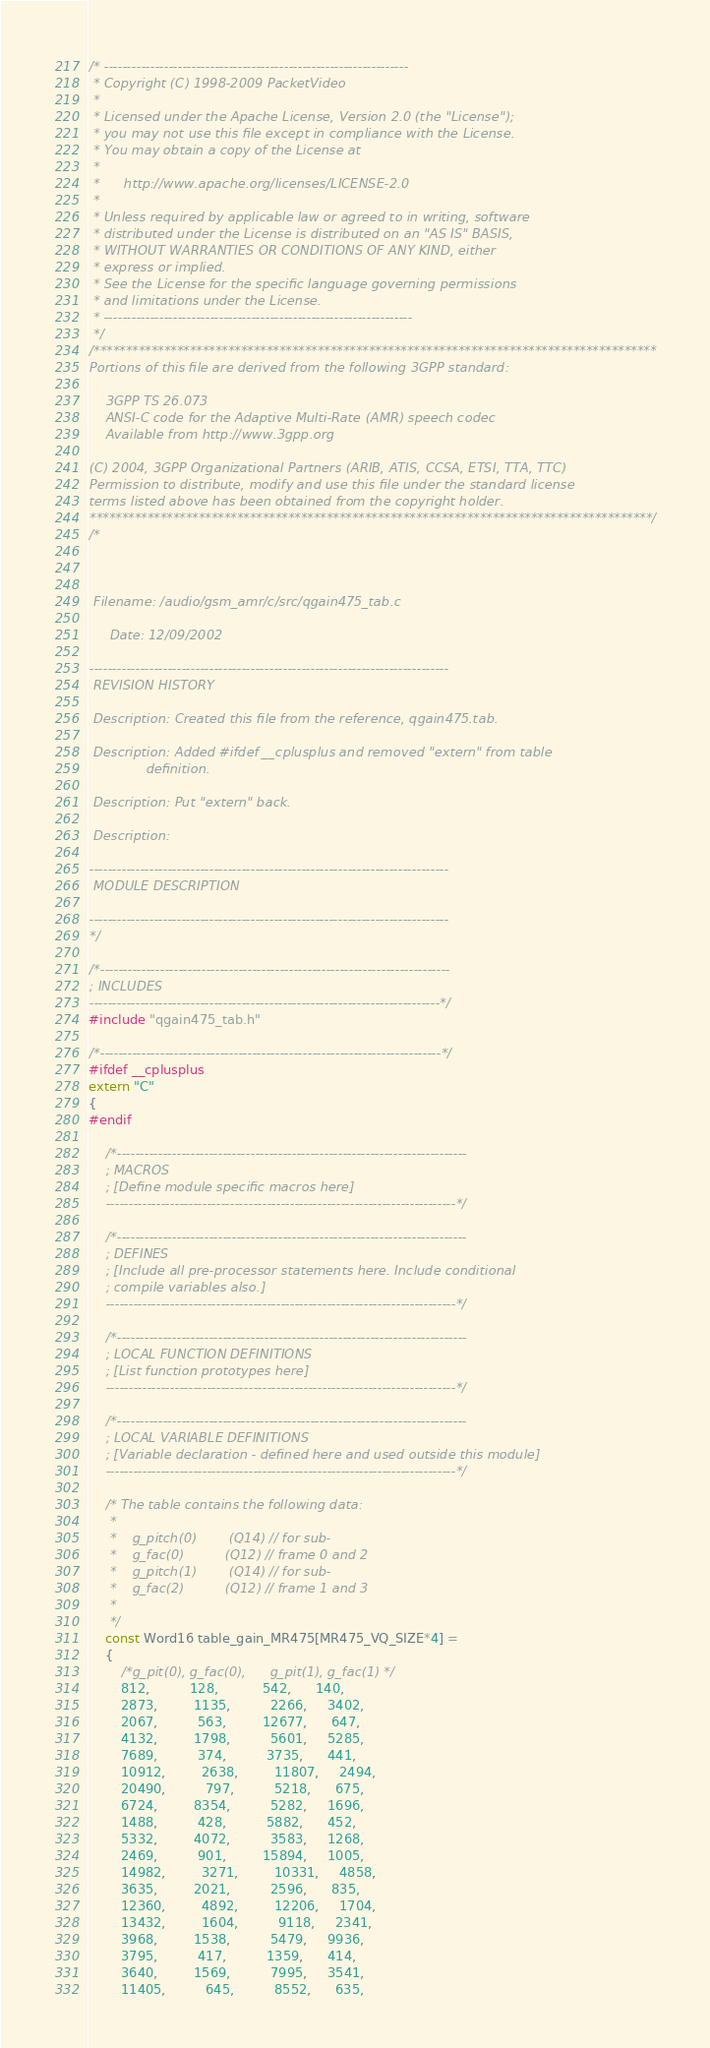<code> <loc_0><loc_0><loc_500><loc_500><_C++_>/* ------------------------------------------------------------------
 * Copyright (C) 1998-2009 PacketVideo
 *
 * Licensed under the Apache License, Version 2.0 (the "License");
 * you may not use this file except in compliance with the License.
 * You may obtain a copy of the License at
 *
 *      http://www.apache.org/licenses/LICENSE-2.0
 *
 * Unless required by applicable law or agreed to in writing, software
 * distributed under the License is distributed on an "AS IS" BASIS,
 * WITHOUT WARRANTIES OR CONDITIONS OF ANY KIND, either
 * express or implied.
 * See the License for the specific language governing permissions
 * and limitations under the License.
 * -------------------------------------------------------------------
 */
/****************************************************************************************
Portions of this file are derived from the following 3GPP standard:

    3GPP TS 26.073
    ANSI-C code for the Adaptive Multi-Rate (AMR) speech codec
    Available from http://www.3gpp.org

(C) 2004, 3GPP Organizational Partners (ARIB, ATIS, CCSA, ETSI, TTA, TTC)
Permission to distribute, modify and use this file under the standard license
terms listed above has been obtained from the copyright holder.
****************************************************************************************/
/*



 Filename: /audio/gsm_amr/c/src/qgain475_tab.c

     Date: 12/09/2002

------------------------------------------------------------------------------
 REVISION HISTORY

 Description: Created this file from the reference, qgain475.tab.

 Description: Added #ifdef __cplusplus and removed "extern" from table
              definition.

 Description: Put "extern" back.

 Description:

------------------------------------------------------------------------------
 MODULE DESCRIPTION

------------------------------------------------------------------------------
*/

/*----------------------------------------------------------------------------
; INCLUDES
----------------------------------------------------------------------------*/
#include "qgain475_tab.h"

/*--------------------------------------------------------------------------*/
#ifdef __cplusplus
extern "C"
{
#endif

    /*----------------------------------------------------------------------------
    ; MACROS
    ; [Define module specific macros here]
    ----------------------------------------------------------------------------*/

    /*----------------------------------------------------------------------------
    ; DEFINES
    ; [Include all pre-processor statements here. Include conditional
    ; compile variables also.]
    ----------------------------------------------------------------------------*/

    /*----------------------------------------------------------------------------
    ; LOCAL FUNCTION DEFINITIONS
    ; [List function prototypes here]
    ----------------------------------------------------------------------------*/

    /*----------------------------------------------------------------------------
    ; LOCAL VARIABLE DEFINITIONS
    ; [Variable declaration - defined here and used outside this module]
    ----------------------------------------------------------------------------*/

    /* The table contains the following data:
     *
     *    g_pitch(0)        (Q14) // for sub-
     *    g_fac(0)          (Q12) // frame 0 and 2
     *    g_pitch(1)        (Q14) // for sub-
     *    g_fac(2)          (Q12) // frame 1 and 3
     *
     */
    const Word16 table_gain_MR475[MR475_VQ_SIZE*4] =
    {
        /*g_pit(0), g_fac(0),      g_pit(1), g_fac(1) */
        812,          128,           542,      140,
        2873,         1135,          2266,     3402,
        2067,          563,         12677,      647,
        4132,         1798,          5601,     5285,
        7689,          374,          3735,      441,
        10912,         2638,         11807,     2494,
        20490,          797,          5218,      675,
        6724,         8354,          5282,     1696,
        1488,          428,          5882,      452,
        5332,         4072,          3583,     1268,
        2469,          901,         15894,     1005,
        14982,         3271,         10331,     4858,
        3635,         2021,          2596,      835,
        12360,         4892,         12206,     1704,
        13432,         1604,          9118,     2341,
        3968,         1538,          5479,     9936,
        3795,          417,          1359,      414,
        3640,         1569,          7995,     3541,
        11405,          645,          8552,      635,</code> 